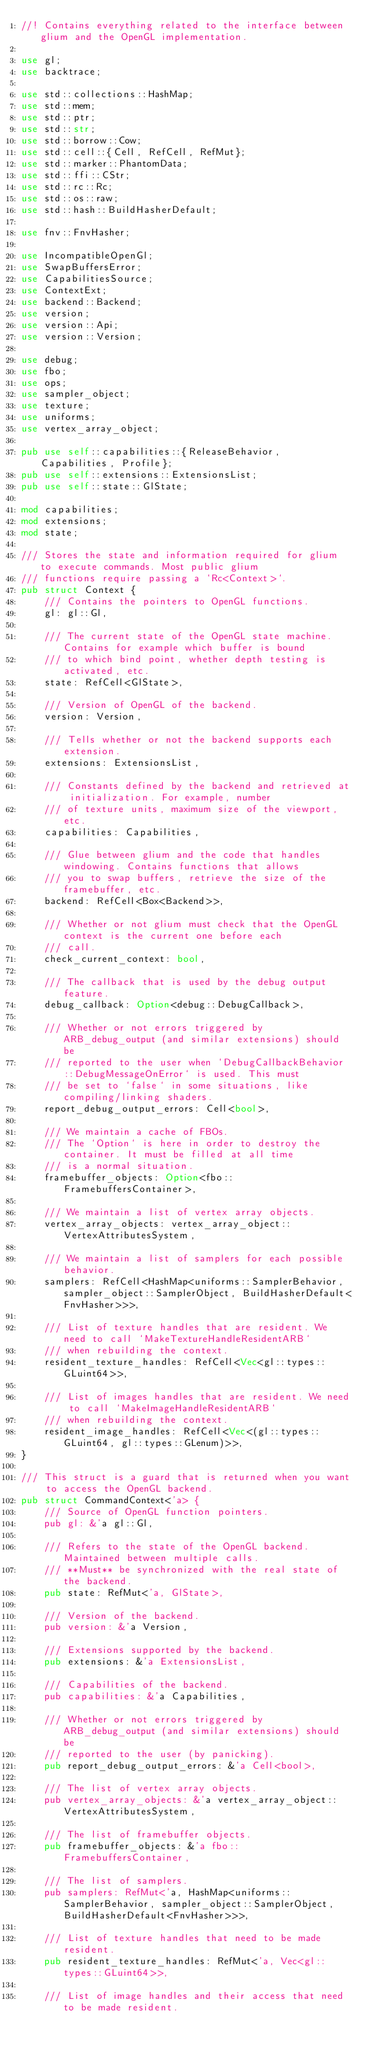<code> <loc_0><loc_0><loc_500><loc_500><_Rust_>//! Contains everything related to the interface between glium and the OpenGL implementation.

use gl;
use backtrace;

use std::collections::HashMap;
use std::mem;
use std::ptr;
use std::str;
use std::borrow::Cow;
use std::cell::{Cell, RefCell, RefMut};
use std::marker::PhantomData;
use std::ffi::CStr;
use std::rc::Rc;
use std::os::raw;
use std::hash::BuildHasherDefault;

use fnv::FnvHasher;

use IncompatibleOpenGl;
use SwapBuffersError;
use CapabilitiesSource;
use ContextExt;
use backend::Backend;
use version;
use version::Api;
use version::Version;

use debug;
use fbo;
use ops;
use sampler_object;
use texture;
use uniforms;
use vertex_array_object;

pub use self::capabilities::{ReleaseBehavior, Capabilities, Profile};
pub use self::extensions::ExtensionsList;
pub use self::state::GlState;

mod capabilities;
mod extensions;
mod state;

/// Stores the state and information required for glium to execute commands. Most public glium
/// functions require passing a `Rc<Context>`.
pub struct Context {
    /// Contains the pointers to OpenGL functions.
    gl: gl::Gl,

    /// The current state of the OpenGL state machine. Contains for example which buffer is bound
    /// to which bind point, whether depth testing is activated, etc.
    state: RefCell<GlState>,

    /// Version of OpenGL of the backend.
    version: Version,

    /// Tells whether or not the backend supports each extension.
    extensions: ExtensionsList,

    /// Constants defined by the backend and retrieved at initialization. For example, number
    /// of texture units, maximum size of the viewport, etc.
    capabilities: Capabilities,

    /// Glue between glium and the code that handles windowing. Contains functions that allows
    /// you to swap buffers, retrieve the size of the framebuffer, etc.
    backend: RefCell<Box<Backend>>,

    /// Whether or not glium must check that the OpenGL context is the current one before each
    /// call.
    check_current_context: bool,

    /// The callback that is used by the debug output feature.
    debug_callback: Option<debug::DebugCallback>,

    /// Whether or not errors triggered by ARB_debug_output (and similar extensions) should be
    /// reported to the user when `DebugCallbackBehavior::DebugMessageOnError` is used. This must
    /// be set to `false` in some situations, like compiling/linking shaders.
    report_debug_output_errors: Cell<bool>,

    /// We maintain a cache of FBOs.
    /// The `Option` is here in order to destroy the container. It must be filled at all time
    /// is a normal situation.
    framebuffer_objects: Option<fbo::FramebuffersContainer>,

    /// We maintain a list of vertex array objects.
    vertex_array_objects: vertex_array_object::VertexAttributesSystem,

    /// We maintain a list of samplers for each possible behavior.
    samplers: RefCell<HashMap<uniforms::SamplerBehavior, sampler_object::SamplerObject, BuildHasherDefault<FnvHasher>>>,

    /// List of texture handles that are resident. We need to call `MakeTextureHandleResidentARB`
    /// when rebuilding the context.
    resident_texture_handles: RefCell<Vec<gl::types::GLuint64>>,

    /// List of images handles that are resident. We need to call `MakeImageHandleResidentARB`
    /// when rebuilding the context.
    resident_image_handles: RefCell<Vec<(gl::types::GLuint64, gl::types::GLenum)>>,
}

/// This struct is a guard that is returned when you want to access the OpenGL backend.
pub struct CommandContext<'a> {
    /// Source of OpenGL function pointers.
    pub gl: &'a gl::Gl,

    /// Refers to the state of the OpenGL backend. Maintained between multiple calls.
    /// **Must** be synchronized with the real state of the backend.
    pub state: RefMut<'a, GlState>,

    /// Version of the backend.
    pub version: &'a Version,

    /// Extensions supported by the backend.
    pub extensions: &'a ExtensionsList,

    /// Capabilities of the backend.
    pub capabilities: &'a Capabilities,

    /// Whether or not errors triggered by ARB_debug_output (and similar extensions) should be
    /// reported to the user (by panicking).
    pub report_debug_output_errors: &'a Cell<bool>,

    /// The list of vertex array objects.
    pub vertex_array_objects: &'a vertex_array_object::VertexAttributesSystem,

    /// The list of framebuffer objects.
    pub framebuffer_objects: &'a fbo::FramebuffersContainer,

    /// The list of samplers.
    pub samplers: RefMut<'a, HashMap<uniforms::SamplerBehavior, sampler_object::SamplerObject, BuildHasherDefault<FnvHasher>>>,

    /// List of texture handles that need to be made resident.
    pub resident_texture_handles: RefMut<'a, Vec<gl::types::GLuint64>>,

    /// List of image handles and their access that need to be made resident.</code> 